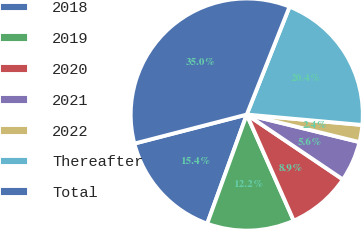Convert chart. <chart><loc_0><loc_0><loc_500><loc_500><pie_chart><fcel>2018<fcel>2019<fcel>2020<fcel>2021<fcel>2022<fcel>Thereafter<fcel>Total<nl><fcel>15.44%<fcel>12.17%<fcel>8.91%<fcel>5.64%<fcel>2.38%<fcel>20.42%<fcel>35.03%<nl></chart> 